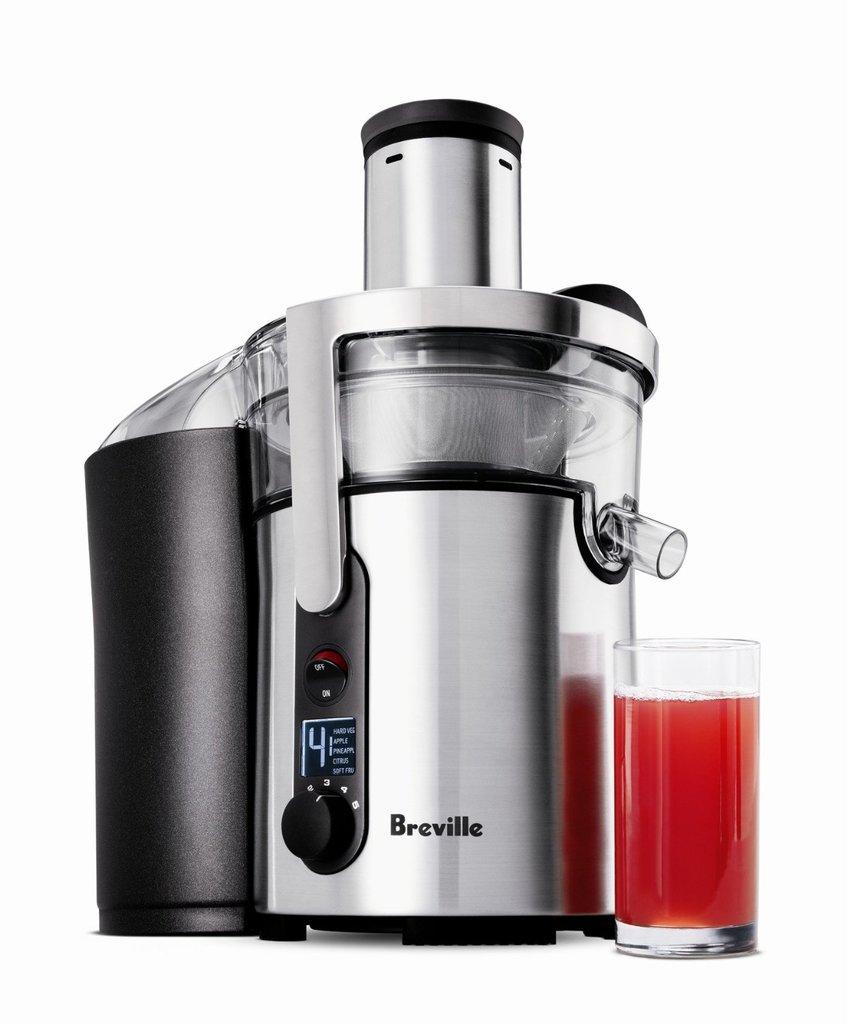What brand is this machine?
Give a very brief answer. Breville. 